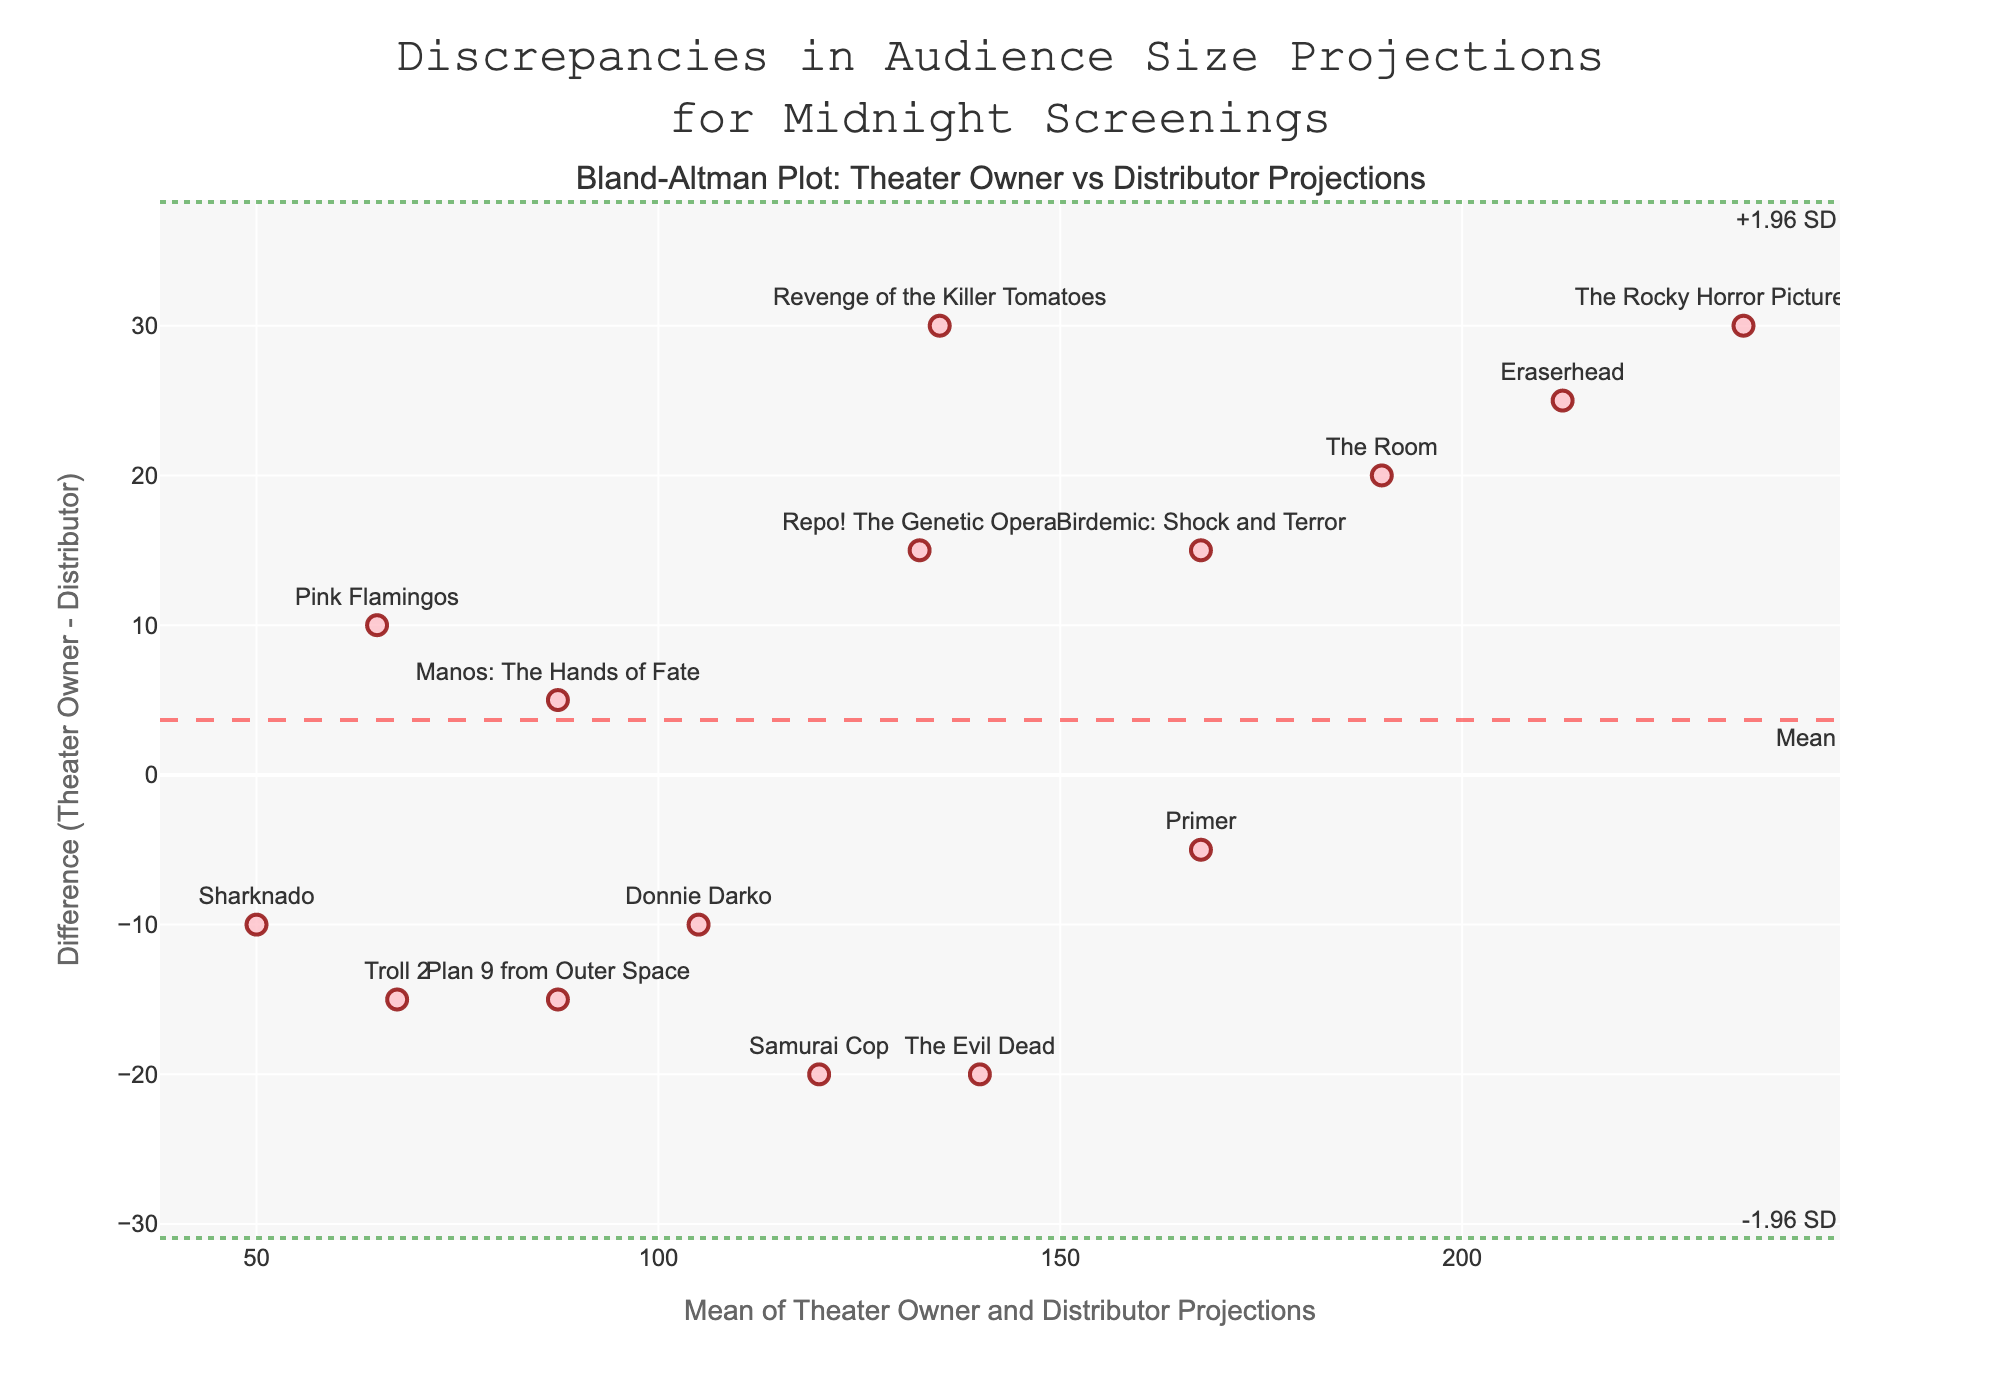How many midnight screenings' audience size projections are compared in the plot? To determine this, you would count the number of data points (markers) on the plot. Each point on the Bland–Altman plot represents a single midnight screening's audience size projection.
Answer: 15 What is the title of the plot? The title is typically displayed prominently at the top of the plot. It gives an overview of what the plot represents. In this case, you would find the title above the plot area.
Answer: Discrepancies in Audience Size Projections for Midnight Screenings Which midnight screening has the largest positive discrepancy between theater owner and distributor projections? To find this, look for the data point with the maximum positive difference (y-coordinate). Identify the film title associated with this point.
Answer: The Rocky Horror Picture Show What's the range of the differences between theater owners' and distributors' projections? The range is the difference between the largest and smallest values. Locate the highest positive and the lowest negative discrepancies (y-values) and compute their difference. The data points span from a minimum difference of -15 (Plan 9 from Outer Space) to a maximum difference of 30 (The Rocky Horror Picture Show).
Answer: 45 What's the position of the mean difference line in the plot? The mean difference line is indicated by the dashed line across the middle of the plot; it runs horizontally and is normally labeled 'Mean'. The y-coordinate where this line is placed is the mean difference value.
Answer: 7 Is "Birdemic: Shock and Terror" one of the midnight screenings with a discrepancy beyond the limits of agreement? Check the y-value of "Birdemic: Shock and Terror" and compare it with the upper and lower limits of agreement. If its y-coordinate falls outside these dashed lines, it is beyond the limits of agreement.
Answer: No Which midnight screening has the closest agreement between the theater owner and distributor projections? The closest agreement would be the point where the difference (y-value) is zero or closest to zero. Locate the data point nearest to the horizontal axis where y=0 and identify the film.
Answer: Manos: The Hands of Fate How many midnight screenings have discrepancies within one standard deviation from the mean difference? To answer this, you need to count how many data points fall within the upper and lower limits of one standard deviation (mean difference ± 1 SD).
Answer: 14 